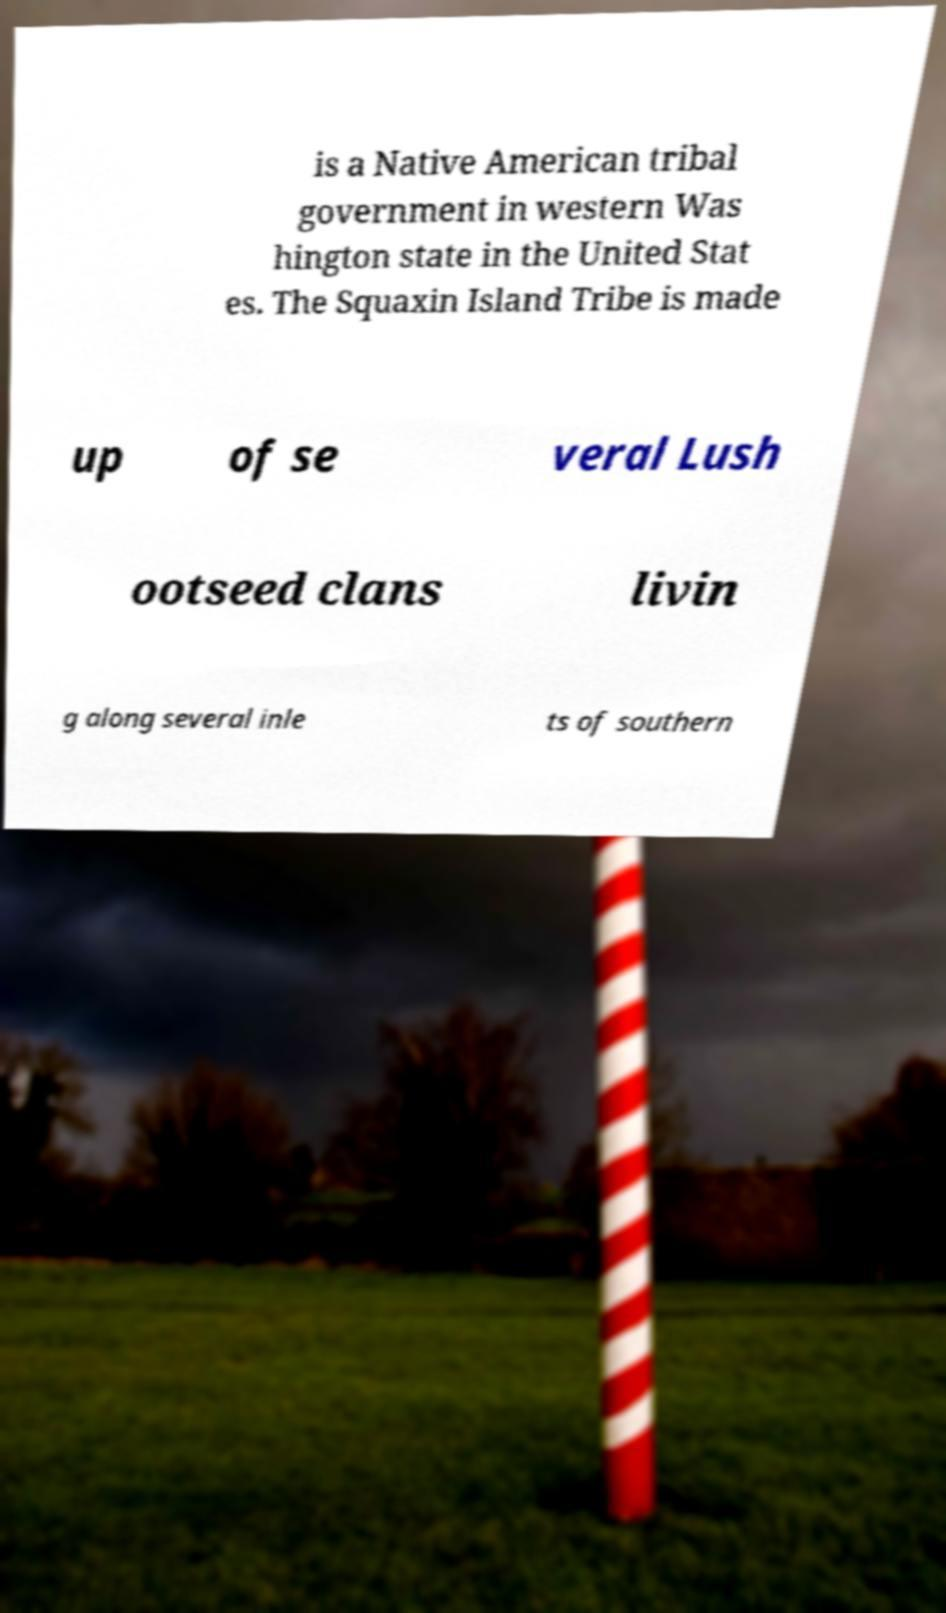Could you assist in decoding the text presented in this image and type it out clearly? is a Native American tribal government in western Was hington state in the United Stat es. The Squaxin Island Tribe is made up of se veral Lush ootseed clans livin g along several inle ts of southern 